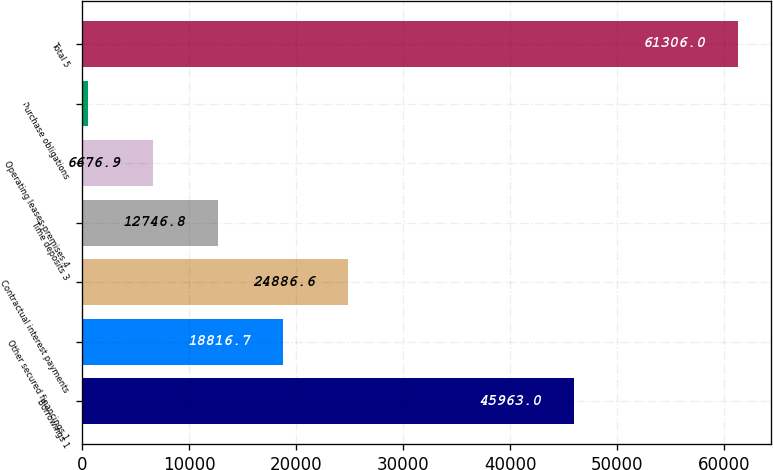Convert chart to OTSL. <chart><loc_0><loc_0><loc_500><loc_500><bar_chart><fcel>Borrowings 1<fcel>Other secured financings 1<fcel>Contractual interest payments<fcel>Time deposits 3<fcel>Operating leases-premises 4<fcel>Purchase obligations<fcel>Total 5<nl><fcel>45963<fcel>18816.7<fcel>24886.6<fcel>12746.8<fcel>6676.9<fcel>607<fcel>61306<nl></chart> 